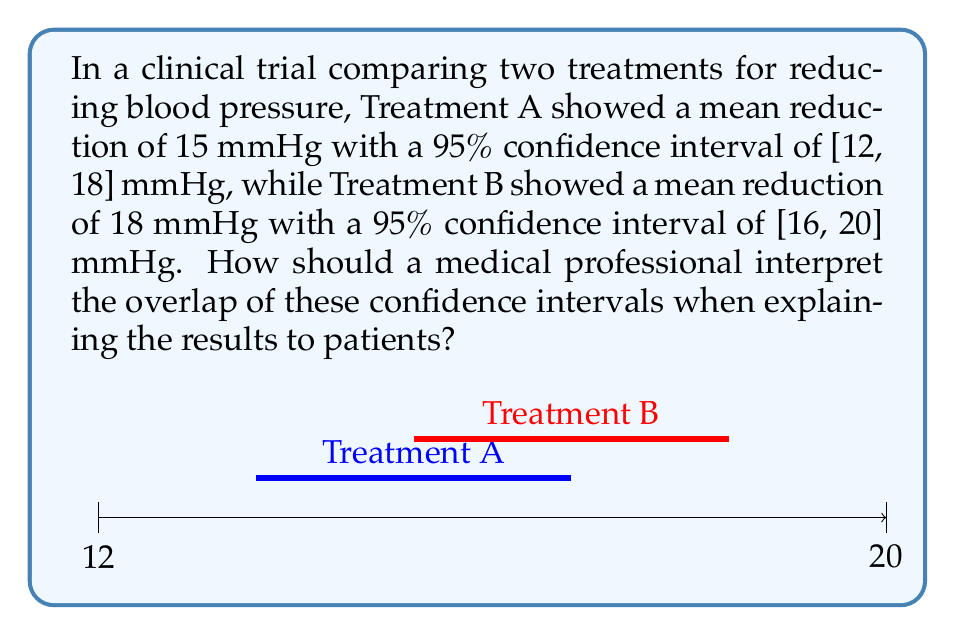Help me with this question. To interpret the overlap of confidence intervals for different medical treatments, we need to follow these steps:

1. Identify the confidence intervals:
   Treatment A: [12, 18] mmHg
   Treatment B: [16, 20] mmHg

2. Determine if there is an overlap:
   The intervals overlap in the range [16, 18] mmHg.

3. Interpret the overlap:
   a) When confidence intervals overlap, it suggests that the true difference between the treatments may not be statistically significant at the given confidence level (95% in this case).
   
   b) The overlap indicates that there is a possibility that the true effect of both treatments could be the same, somewhere in the overlapping region.

4. Consider the clinical significance:
   Even if the difference is not statistically significant, the observed difference (18 mmHg for Treatment B vs. 15 mmHg for Treatment A) may still be clinically relevant.

5. Explain limitations:
   Confidence intervals provide a range of plausible values for the true effect, not a definitive answer. The width of the intervals indicates the precision of the estimates.

6. Recommendation:
   While Treatment B shows a slightly larger mean reduction, the overlapping confidence intervals suggest that both treatments may be similarly effective. Additional factors such as side effects, cost, and patient preferences should be considered when choosing between treatments.
Answer: The overlapping confidence intervals suggest that the difference between treatments may not be statistically significant, but both appear effective in reducing blood pressure. Consider clinical significance and other factors when recommending treatment. 